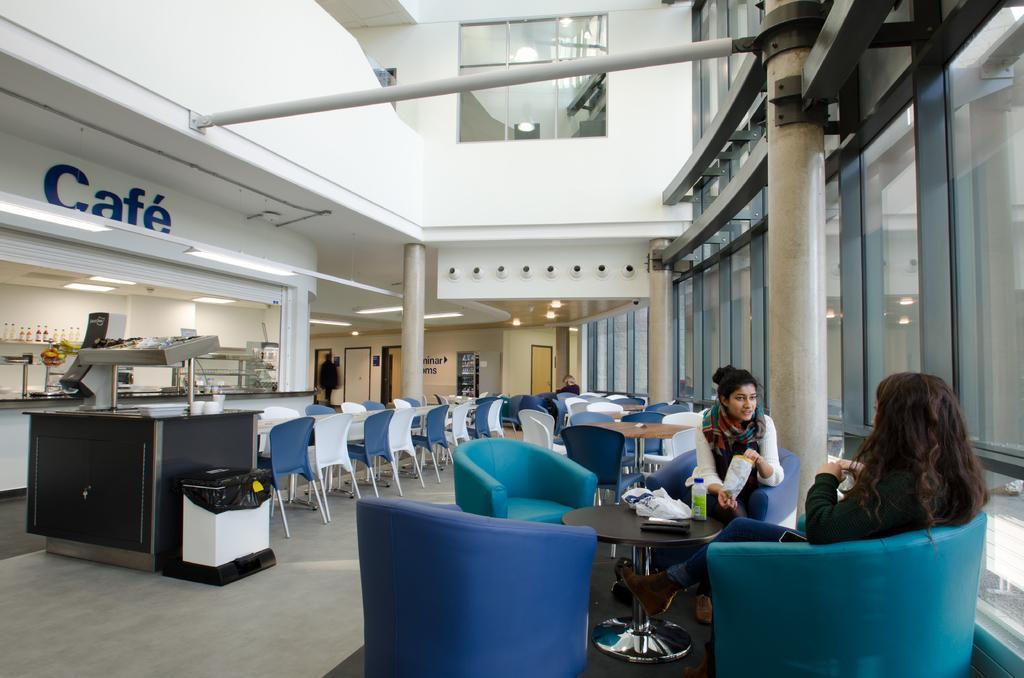In one or two sentences, can you explain what this image depicts? Two women are sitting in a coffee shop talking to each other. 